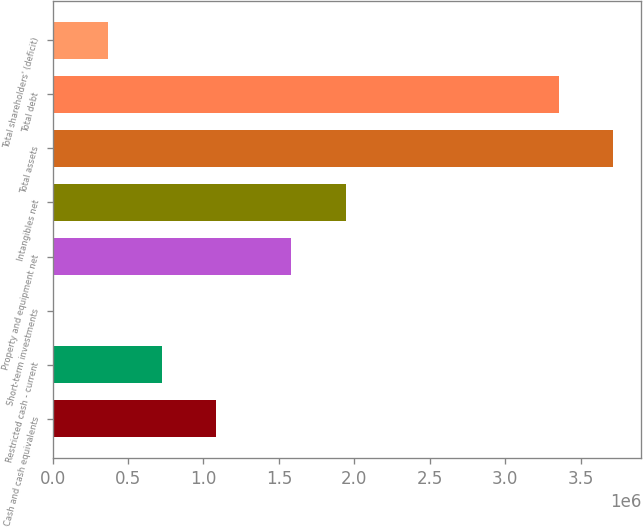Convert chart to OTSL. <chart><loc_0><loc_0><loc_500><loc_500><bar_chart><fcel>Cash and cash equivalents<fcel>Restricted cash - current<fcel>Short-term investments<fcel>Property and equipment net<fcel>Intangibles net<fcel>Total assets<fcel>Total debt<fcel>Total shareholders' (deficit)<nl><fcel>1.08596e+06<fcel>725898<fcel>5773<fcel>1.58339e+06<fcel>1.94346e+06<fcel>3.71455e+06<fcel>3.35448e+06<fcel>365836<nl></chart> 